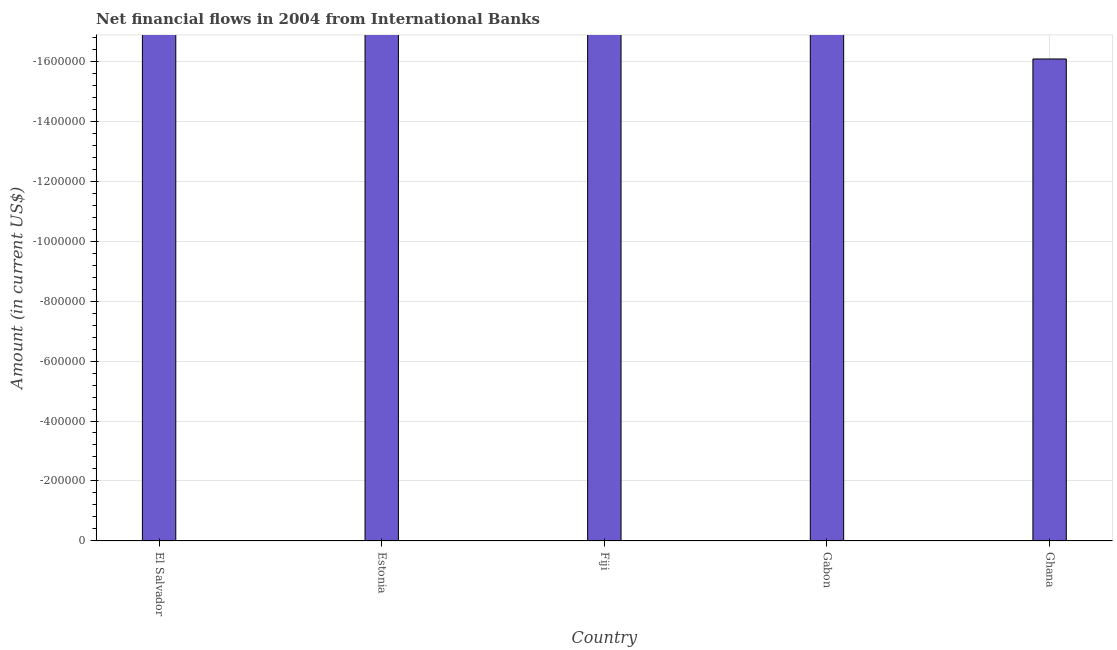Does the graph contain any zero values?
Provide a succinct answer. Yes. What is the title of the graph?
Make the answer very short. Net financial flows in 2004 from International Banks. What is the label or title of the X-axis?
Your response must be concise. Country. What is the sum of the net financial flows from ibrd?
Give a very brief answer. 0. What is the median net financial flows from ibrd?
Give a very brief answer. 0. In how many countries, is the net financial flows from ibrd greater than the average net financial flows from ibrd taken over all countries?
Make the answer very short. 0. How many bars are there?
Ensure brevity in your answer.  0. Are all the bars in the graph horizontal?
Ensure brevity in your answer.  No. How many countries are there in the graph?
Ensure brevity in your answer.  5. What is the difference between two consecutive major ticks on the Y-axis?
Make the answer very short. 2.00e+05. Are the values on the major ticks of Y-axis written in scientific E-notation?
Offer a very short reply. No. What is the Amount (in current US$) in El Salvador?
Ensure brevity in your answer.  0. What is the Amount (in current US$) of Fiji?
Make the answer very short. 0. What is the Amount (in current US$) of Gabon?
Your answer should be compact. 0. 